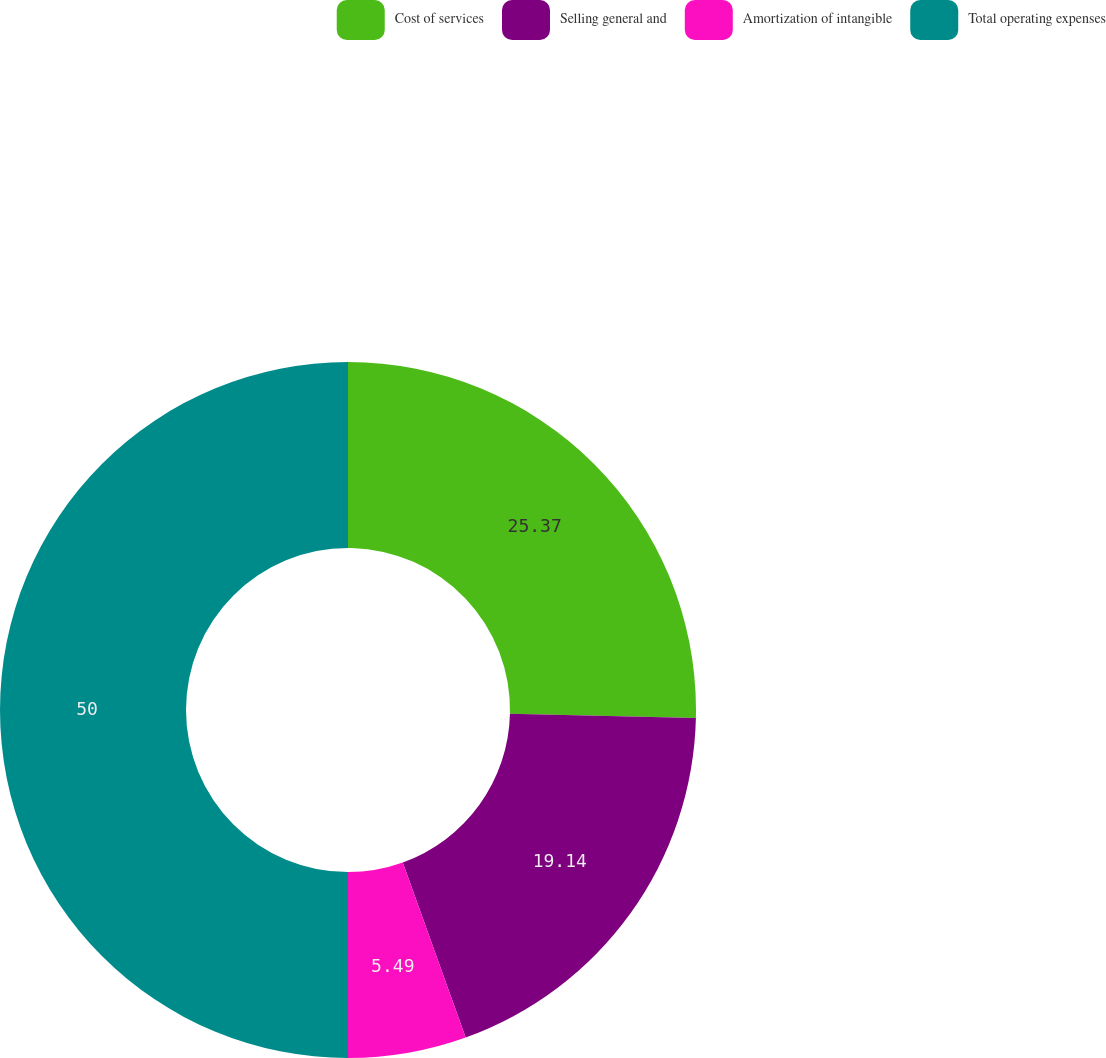Convert chart. <chart><loc_0><loc_0><loc_500><loc_500><pie_chart><fcel>Cost of services<fcel>Selling general and<fcel>Amortization of intangible<fcel>Total operating expenses<nl><fcel>25.37%<fcel>19.14%<fcel>5.49%<fcel>50.0%<nl></chart> 